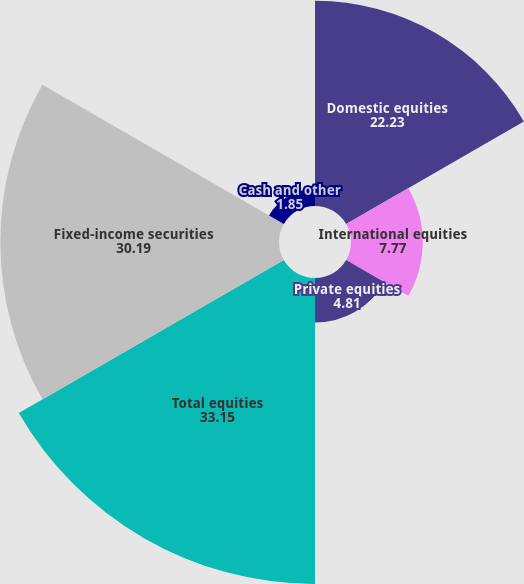Convert chart. <chart><loc_0><loc_0><loc_500><loc_500><pie_chart><fcel>Domestic equities<fcel>International equities<fcel>Private equities<fcel>Total equities<fcel>Fixed-income securities<fcel>Cash and other<nl><fcel>22.23%<fcel>7.77%<fcel>4.81%<fcel>33.15%<fcel>30.19%<fcel>1.85%<nl></chart> 